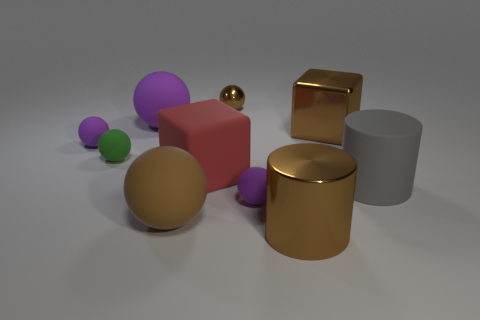Does the tiny green object have the same shape as the small metallic object?
Provide a short and direct response. Yes. There is a rubber thing that is both on the right side of the big matte cube and on the left side of the large gray matte cylinder; what is its color?
Your answer should be very brief. Purple. Is the size of the brown ball that is behind the large brown block the same as the green object on the left side of the big brown metal cube?
Offer a terse response. Yes. What number of things are either big matte spheres right of the big purple rubber object or brown things?
Ensure brevity in your answer.  4. What is the material of the large gray cylinder?
Give a very brief answer. Rubber. Does the green matte sphere have the same size as the shiny ball?
Your answer should be very brief. Yes. How many spheres are either large gray rubber objects or blue rubber objects?
Offer a terse response. 0. What color is the shiny object that is in front of the brown sphere that is in front of the green rubber thing?
Ensure brevity in your answer.  Brown. Are there fewer brown metallic objects behind the rubber cylinder than matte objects in front of the big brown metallic cube?
Your answer should be compact. Yes. Do the green ball and the rubber object left of the small green matte thing have the same size?
Your answer should be very brief. Yes. 